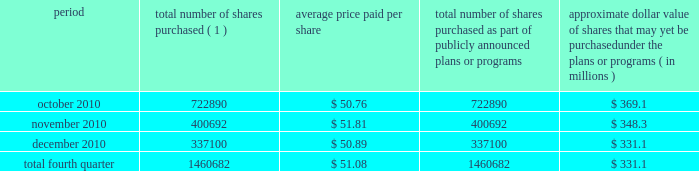Issuer purchases of equity securities during the three months ended december 31 , 2010 , we repurchased 1460682 shares of our common stock for an aggregate of $ 74.6 million , including commissions and fees , pursuant to our publicly announced stock repurchase program , as follows : period total number of shares purchased ( 1 ) average price paid per share total number of shares purchased as part of publicly announced plans or programs approximate dollar value of shares that may yet be purchased under the plans or programs ( in millions ) .
( 1 ) repurchases made pursuant to the $ 1.5 billion stock repurchase program approved by our board of directors in february 2008 ( the 201cbuyback 201d ) .
Under this program , our management is authorized to purchase shares from time to time through open market purchases or privately negotiated transactions at prevailing prices as permitted by securities laws and other legal requirements , and subject to market conditions and other factors .
To facilitate repurchases , we make purchases pursuant to trading plans under rule 10b5-1 of the exchange act , which allows us to repurchase shares during periods when we otherwise might be prevented from doing so under insider trading laws or because of self-imposed trading blackout periods .
This program may be discontinued at any time .
Subsequent to december 31 , 2010 , we repurchased 1122481 shares of our common stock for an aggregate of $ 58.0 million , including commissions and fees , pursuant to the buyback .
As of february 11 , 2011 , we had repurchased a total of 30.9 million shares of our common stock for an aggregate of $ 1.2 billion , including commissions and fees pursuant to the buyback .
We expect to continue to manage the pacing of the remaining $ 273.1 million under the buyback in response to general market conditions and other relevant factors. .
What portion of total shares repurchased in the fourth quarter of 2010 occurred during december? 
Computations: (337100 / 1460682)
Answer: 0.23078. 